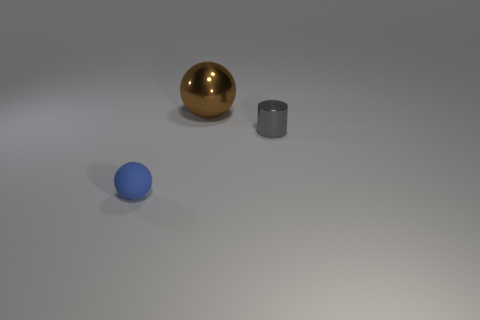There is a tiny gray shiny object; what shape is it? The tiny gray object in the image appears to have a cylindrical shape, characterized by its circular base and elongated straight sides—it's a classic example of a cylinder. The shiny surface suggests it's made of a reflective metal or similar material. 